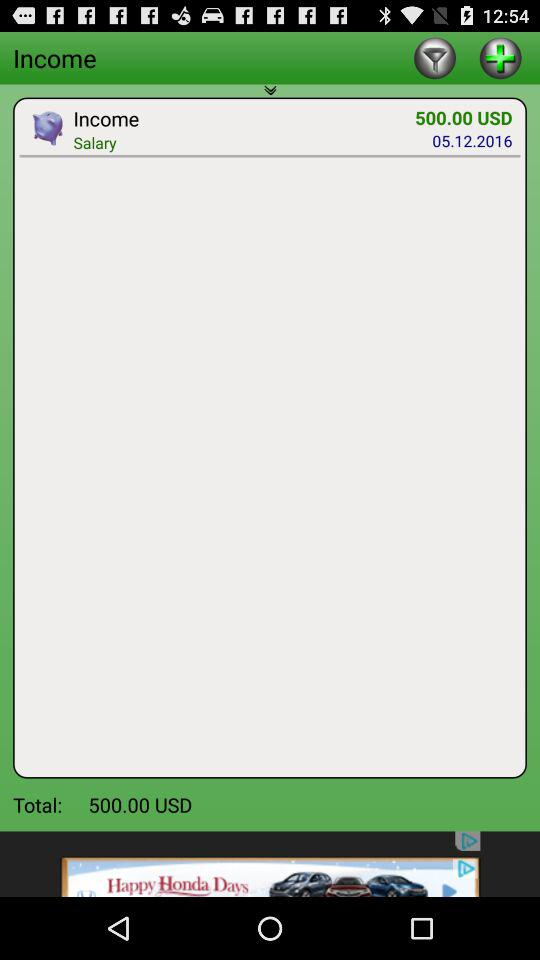How much is the total salary? The total salary is USD 500.00. 